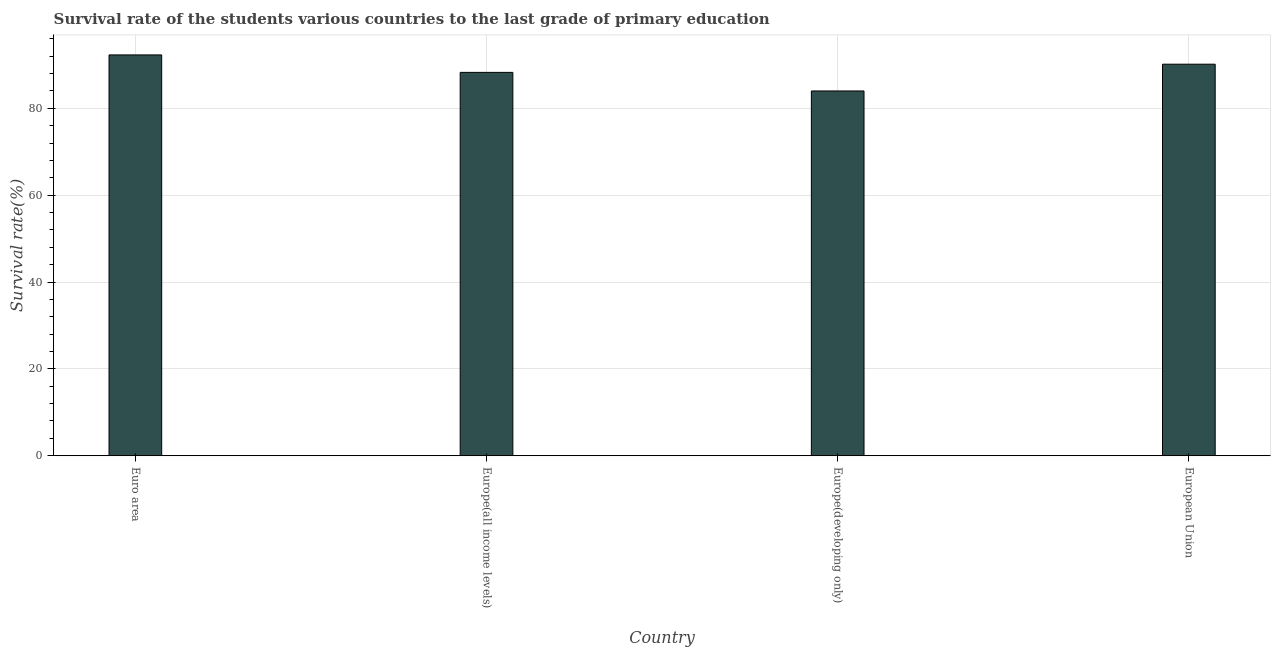Does the graph contain any zero values?
Ensure brevity in your answer.  No. Does the graph contain grids?
Provide a short and direct response. Yes. What is the title of the graph?
Your answer should be very brief. Survival rate of the students various countries to the last grade of primary education. What is the label or title of the Y-axis?
Provide a succinct answer. Survival rate(%). What is the survival rate in primary education in Europe(all income levels)?
Ensure brevity in your answer.  88.28. Across all countries, what is the maximum survival rate in primary education?
Give a very brief answer. 92.31. Across all countries, what is the minimum survival rate in primary education?
Give a very brief answer. 84.01. In which country was the survival rate in primary education maximum?
Your answer should be compact. Euro area. In which country was the survival rate in primary education minimum?
Give a very brief answer. Europe(developing only). What is the sum of the survival rate in primary education?
Make the answer very short. 354.77. What is the difference between the survival rate in primary education in Europe(all income levels) and Europe(developing only)?
Your response must be concise. 4.28. What is the average survival rate in primary education per country?
Your answer should be compact. 88.69. What is the median survival rate in primary education?
Provide a short and direct response. 89.23. What is the ratio of the survival rate in primary education in Euro area to that in Europe(all income levels)?
Keep it short and to the point. 1.05. Is the survival rate in primary education in Euro area less than that in Europe(developing only)?
Ensure brevity in your answer.  No. Is the difference between the survival rate in primary education in Euro area and Europe(all income levels) greater than the difference between any two countries?
Ensure brevity in your answer.  No. What is the difference between the highest and the second highest survival rate in primary education?
Give a very brief answer. 2.14. Are all the bars in the graph horizontal?
Provide a short and direct response. No. What is the difference between two consecutive major ticks on the Y-axis?
Your answer should be very brief. 20. Are the values on the major ticks of Y-axis written in scientific E-notation?
Offer a very short reply. No. What is the Survival rate(%) in Euro area?
Your answer should be compact. 92.31. What is the Survival rate(%) in Europe(all income levels)?
Your response must be concise. 88.28. What is the Survival rate(%) in Europe(developing only)?
Keep it short and to the point. 84.01. What is the Survival rate(%) of European Union?
Keep it short and to the point. 90.17. What is the difference between the Survival rate(%) in Euro area and Europe(all income levels)?
Give a very brief answer. 4.02. What is the difference between the Survival rate(%) in Euro area and Europe(developing only)?
Your response must be concise. 8.3. What is the difference between the Survival rate(%) in Euro area and European Union?
Give a very brief answer. 2.14. What is the difference between the Survival rate(%) in Europe(all income levels) and Europe(developing only)?
Provide a succinct answer. 4.28. What is the difference between the Survival rate(%) in Europe(all income levels) and European Union?
Keep it short and to the point. -1.89. What is the difference between the Survival rate(%) in Europe(developing only) and European Union?
Offer a very short reply. -6.16. What is the ratio of the Survival rate(%) in Euro area to that in Europe(all income levels)?
Your answer should be compact. 1.05. What is the ratio of the Survival rate(%) in Euro area to that in Europe(developing only)?
Provide a succinct answer. 1.1. What is the ratio of the Survival rate(%) in Europe(all income levels) to that in Europe(developing only)?
Offer a terse response. 1.05. What is the ratio of the Survival rate(%) in Europe(all income levels) to that in European Union?
Your answer should be very brief. 0.98. What is the ratio of the Survival rate(%) in Europe(developing only) to that in European Union?
Ensure brevity in your answer.  0.93. 